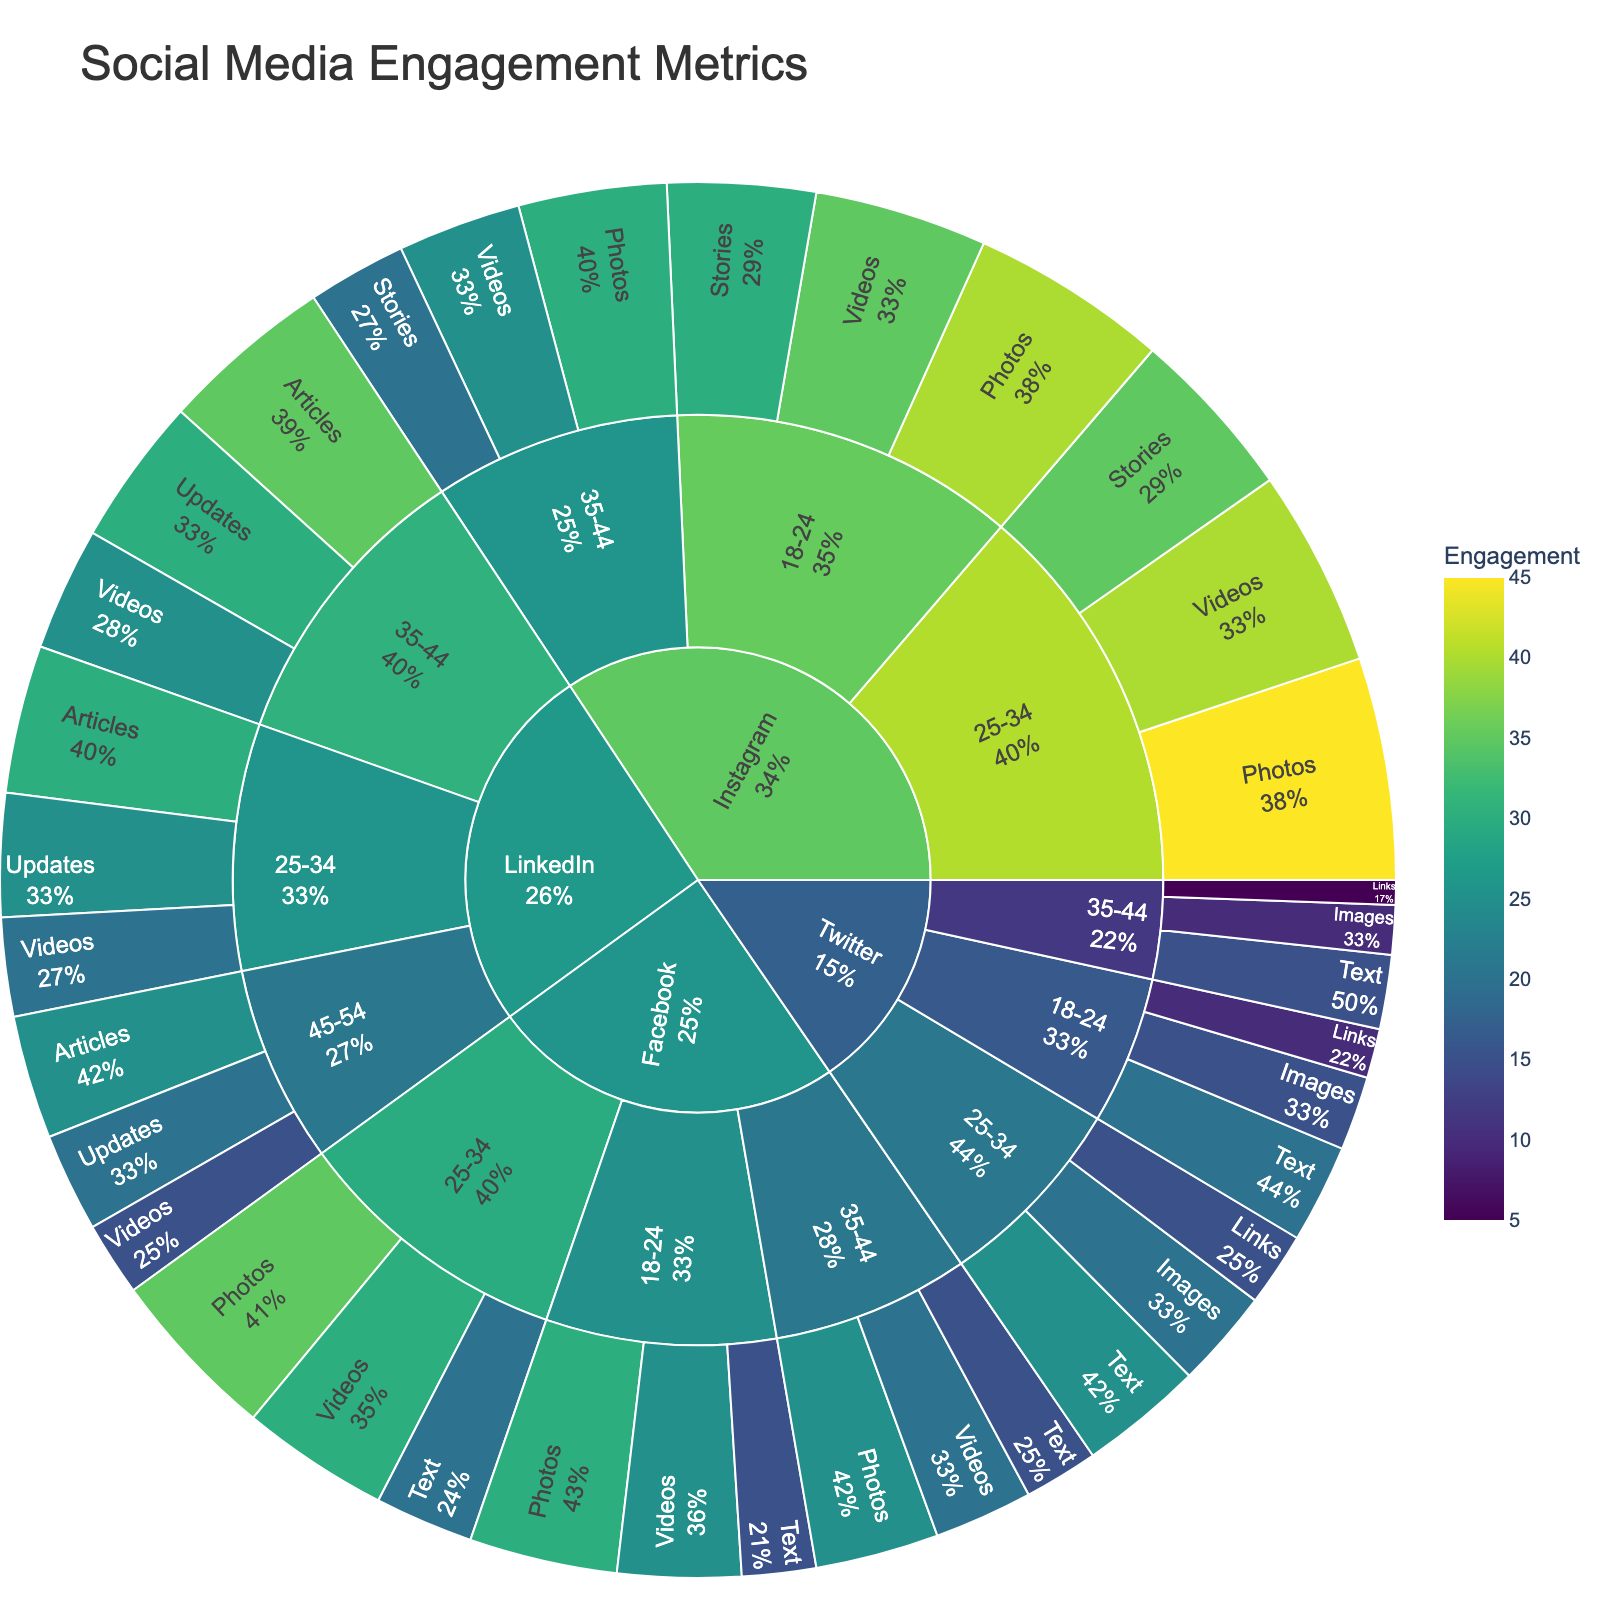What platform has the highest engagement for the age group 18-24? In the sunburst plot, locate the segments for the age group 18-24 under each platform and compare their engagement values. Instagram has the highest values in total across its content types.
Answer: Instagram Which age group has the highest engagement for LinkedIn? Refer to the LinkedIn branch on the sunburst plot and compare the total engagement values for each age group. The 35-44 age group shows the highest engagement.
Answer: 35-44 What is the total engagement for Videos on Instagram for all age groups combined? Sum up the engagement values for Videos under Instagram for each age group; 35 for 18-24, 40 for 25-34, and 25 for 35-44. Hence, 35 + 40 + 25 = 100.
Answer: 100 How does the engagement of Photos on Facebook for the age group 25-34 compare to 35-44? Check the Facebook -> 25-34 -> Photos and Facebook -> 35-44 -> Photos segments on the sunburst plot. The values are 35 and 25, respectively. Therefore, 35 is greater than 25.
Answer: 25-34 has higher engagement Which content type has the least engagement on Twitter for the age group 18-24? Within the Twitter -> 18-24 segment, compare the engagement values for all content types. Links have the lowest engagement value of 10.
Answer: Links What's the average engagement for Photos on Instagram across all age groups? Add up the engagement values for Photos on Instagram across all age groups and divide by the number of age groups. (40 + 45 + 30) / 3 = 115 / 3 = 38.33
Answer: 38.33 Which platform shows engagement for all the provided age groups and content types? Check if all provided age groups and their content types are shown under each platform in the sunburst plot. Facebook, Instagram, and Twitter show engagement for all listed types for their respective age groups.
Answer: Facebook, Instagram, Twitter How does the engagement for Stories on Instagram for age group 18-24 compare to 25-34? Check the Instagram -> 18-24 -> Stories and Instagram -> 25-34 -> Stories segments on the sunburst plot. The values are 30 and 35, respectively. So, 25-34 has more engagement for Stories.
Answer: 25-34 is higher What is the total engagement for content types on LinkedIn for the age group 45-54? Sum up the engagement values for all content types under LinkedIn -> 45-54, which are 25 for Articles, 20 for Updates, and 15 for Videos. Thus, 25 + 20 + 15 = 60.
Answer: 60 